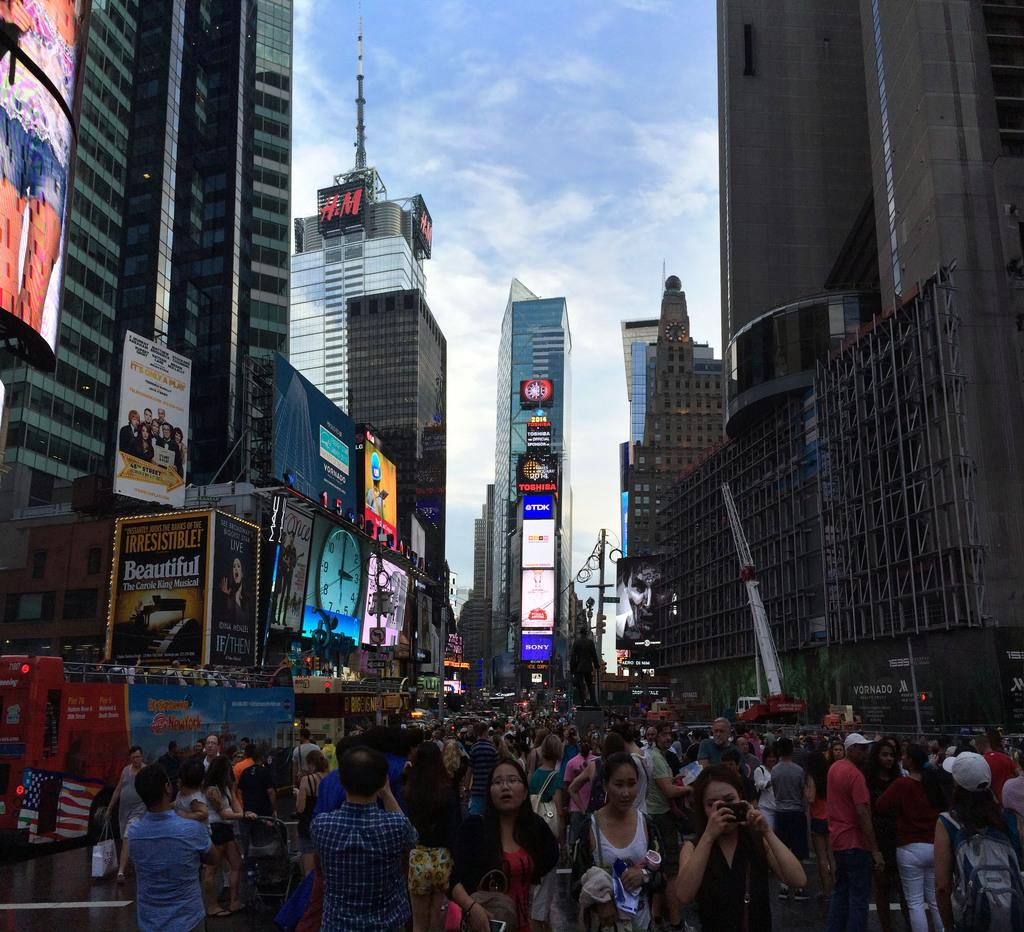<image>
Describe the image concisely. a Toshiba building and many people on the street 